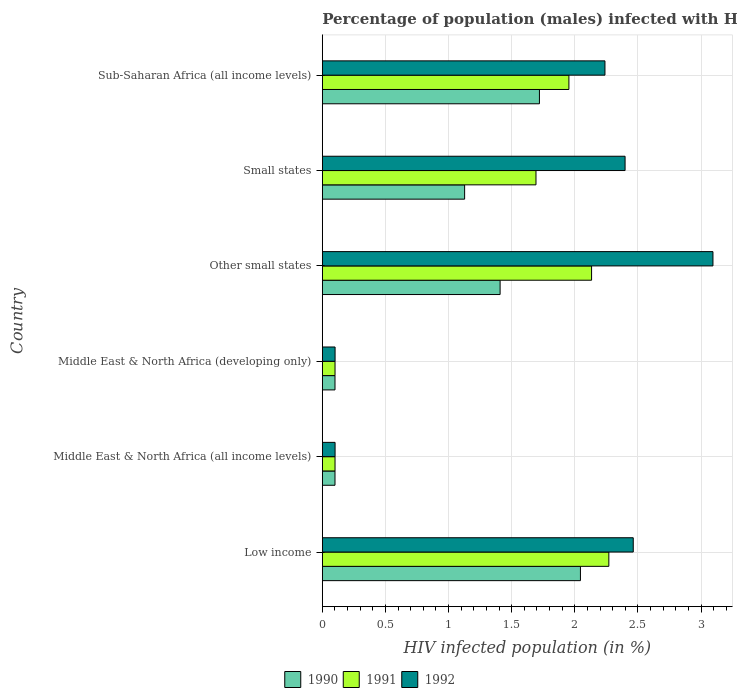How many different coloured bars are there?
Give a very brief answer. 3. How many groups of bars are there?
Ensure brevity in your answer.  6. Are the number of bars per tick equal to the number of legend labels?
Ensure brevity in your answer.  Yes. What is the label of the 1st group of bars from the top?
Your answer should be very brief. Sub-Saharan Africa (all income levels). In how many cases, is the number of bars for a given country not equal to the number of legend labels?
Your response must be concise. 0. What is the percentage of HIV infected male population in 1992 in Middle East & North Africa (developing only)?
Make the answer very short. 0.1. Across all countries, what is the maximum percentage of HIV infected male population in 1992?
Ensure brevity in your answer.  3.09. Across all countries, what is the minimum percentage of HIV infected male population in 1991?
Ensure brevity in your answer.  0.1. In which country was the percentage of HIV infected male population in 1992 maximum?
Your response must be concise. Other small states. In which country was the percentage of HIV infected male population in 1992 minimum?
Ensure brevity in your answer.  Middle East & North Africa (all income levels). What is the total percentage of HIV infected male population in 1990 in the graph?
Your response must be concise. 6.5. What is the difference between the percentage of HIV infected male population in 1992 in Other small states and that in Sub-Saharan Africa (all income levels)?
Ensure brevity in your answer.  0.86. What is the difference between the percentage of HIV infected male population in 1992 in Low income and the percentage of HIV infected male population in 1991 in Middle East & North Africa (all income levels)?
Provide a short and direct response. 2.36. What is the average percentage of HIV infected male population in 1991 per country?
Ensure brevity in your answer.  1.37. What is the difference between the percentage of HIV infected male population in 1991 and percentage of HIV infected male population in 1990 in Small states?
Ensure brevity in your answer.  0.57. What is the ratio of the percentage of HIV infected male population in 1990 in Small states to that in Sub-Saharan Africa (all income levels)?
Your response must be concise. 0.66. What is the difference between the highest and the second highest percentage of HIV infected male population in 1991?
Offer a terse response. 0.14. What is the difference between the highest and the lowest percentage of HIV infected male population in 1990?
Your answer should be very brief. 1.94. In how many countries, is the percentage of HIV infected male population in 1992 greater than the average percentage of HIV infected male population in 1992 taken over all countries?
Ensure brevity in your answer.  4. Is the sum of the percentage of HIV infected male population in 1991 in Low income and Middle East & North Africa (developing only) greater than the maximum percentage of HIV infected male population in 1992 across all countries?
Offer a very short reply. No. What does the 1st bar from the top in Other small states represents?
Provide a succinct answer. 1992. What does the 1st bar from the bottom in Small states represents?
Make the answer very short. 1990. How many bars are there?
Give a very brief answer. 18. Are the values on the major ticks of X-axis written in scientific E-notation?
Make the answer very short. No. Does the graph contain grids?
Ensure brevity in your answer.  Yes. How many legend labels are there?
Keep it short and to the point. 3. How are the legend labels stacked?
Keep it short and to the point. Horizontal. What is the title of the graph?
Your answer should be very brief. Percentage of population (males) infected with HIV. Does "2005" appear as one of the legend labels in the graph?
Ensure brevity in your answer.  No. What is the label or title of the X-axis?
Provide a short and direct response. HIV infected population (in %). What is the label or title of the Y-axis?
Your response must be concise. Country. What is the HIV infected population (in %) in 1990 in Low income?
Your answer should be very brief. 2.04. What is the HIV infected population (in %) of 1991 in Low income?
Make the answer very short. 2.27. What is the HIV infected population (in %) of 1992 in Low income?
Make the answer very short. 2.46. What is the HIV infected population (in %) in 1990 in Middle East & North Africa (all income levels)?
Provide a succinct answer. 0.1. What is the HIV infected population (in %) in 1991 in Middle East & North Africa (all income levels)?
Offer a very short reply. 0.1. What is the HIV infected population (in %) of 1992 in Middle East & North Africa (all income levels)?
Provide a short and direct response. 0.1. What is the HIV infected population (in %) in 1990 in Middle East & North Africa (developing only)?
Provide a succinct answer. 0.1. What is the HIV infected population (in %) in 1991 in Middle East & North Africa (developing only)?
Make the answer very short. 0.1. What is the HIV infected population (in %) in 1992 in Middle East & North Africa (developing only)?
Your answer should be compact. 0.1. What is the HIV infected population (in %) of 1990 in Other small states?
Your response must be concise. 1.41. What is the HIV infected population (in %) of 1991 in Other small states?
Make the answer very short. 2.13. What is the HIV infected population (in %) of 1992 in Other small states?
Offer a very short reply. 3.09. What is the HIV infected population (in %) in 1990 in Small states?
Offer a very short reply. 1.13. What is the HIV infected population (in %) in 1991 in Small states?
Offer a terse response. 1.69. What is the HIV infected population (in %) of 1992 in Small states?
Your answer should be very brief. 2.4. What is the HIV infected population (in %) of 1990 in Sub-Saharan Africa (all income levels)?
Your response must be concise. 1.72. What is the HIV infected population (in %) of 1991 in Sub-Saharan Africa (all income levels)?
Your answer should be compact. 1.95. What is the HIV infected population (in %) of 1992 in Sub-Saharan Africa (all income levels)?
Ensure brevity in your answer.  2.24. Across all countries, what is the maximum HIV infected population (in %) of 1990?
Your answer should be compact. 2.04. Across all countries, what is the maximum HIV infected population (in %) in 1991?
Make the answer very short. 2.27. Across all countries, what is the maximum HIV infected population (in %) of 1992?
Provide a succinct answer. 3.09. Across all countries, what is the minimum HIV infected population (in %) in 1990?
Provide a short and direct response. 0.1. Across all countries, what is the minimum HIV infected population (in %) in 1991?
Your answer should be compact. 0.1. Across all countries, what is the minimum HIV infected population (in %) in 1992?
Offer a terse response. 0.1. What is the total HIV infected population (in %) of 1990 in the graph?
Ensure brevity in your answer.  6.5. What is the total HIV infected population (in %) in 1991 in the graph?
Ensure brevity in your answer.  8.25. What is the total HIV infected population (in %) in 1992 in the graph?
Keep it short and to the point. 10.39. What is the difference between the HIV infected population (in %) in 1990 in Low income and that in Middle East & North Africa (all income levels)?
Provide a short and direct response. 1.94. What is the difference between the HIV infected population (in %) of 1991 in Low income and that in Middle East & North Africa (all income levels)?
Your answer should be compact. 2.17. What is the difference between the HIV infected population (in %) in 1992 in Low income and that in Middle East & North Africa (all income levels)?
Offer a very short reply. 2.36. What is the difference between the HIV infected population (in %) of 1990 in Low income and that in Middle East & North Africa (developing only)?
Your answer should be very brief. 1.94. What is the difference between the HIV infected population (in %) in 1991 in Low income and that in Middle East & North Africa (developing only)?
Offer a very short reply. 2.17. What is the difference between the HIV infected population (in %) of 1992 in Low income and that in Middle East & North Africa (developing only)?
Ensure brevity in your answer.  2.36. What is the difference between the HIV infected population (in %) in 1990 in Low income and that in Other small states?
Your response must be concise. 0.64. What is the difference between the HIV infected population (in %) of 1991 in Low income and that in Other small states?
Ensure brevity in your answer.  0.14. What is the difference between the HIV infected population (in %) in 1992 in Low income and that in Other small states?
Offer a terse response. -0.63. What is the difference between the HIV infected population (in %) in 1990 in Low income and that in Small states?
Offer a very short reply. 0.92. What is the difference between the HIV infected population (in %) of 1991 in Low income and that in Small states?
Offer a terse response. 0.58. What is the difference between the HIV infected population (in %) in 1992 in Low income and that in Small states?
Make the answer very short. 0.06. What is the difference between the HIV infected population (in %) of 1990 in Low income and that in Sub-Saharan Africa (all income levels)?
Offer a very short reply. 0.32. What is the difference between the HIV infected population (in %) of 1991 in Low income and that in Sub-Saharan Africa (all income levels)?
Ensure brevity in your answer.  0.32. What is the difference between the HIV infected population (in %) of 1992 in Low income and that in Sub-Saharan Africa (all income levels)?
Offer a terse response. 0.22. What is the difference between the HIV infected population (in %) in 1991 in Middle East & North Africa (all income levels) and that in Middle East & North Africa (developing only)?
Ensure brevity in your answer.  -0. What is the difference between the HIV infected population (in %) of 1990 in Middle East & North Africa (all income levels) and that in Other small states?
Provide a succinct answer. -1.31. What is the difference between the HIV infected population (in %) in 1991 in Middle East & North Africa (all income levels) and that in Other small states?
Your answer should be compact. -2.03. What is the difference between the HIV infected population (in %) in 1992 in Middle East & North Africa (all income levels) and that in Other small states?
Keep it short and to the point. -2.99. What is the difference between the HIV infected population (in %) in 1990 in Middle East & North Africa (all income levels) and that in Small states?
Provide a short and direct response. -1.03. What is the difference between the HIV infected population (in %) of 1991 in Middle East & North Africa (all income levels) and that in Small states?
Your answer should be compact. -1.59. What is the difference between the HIV infected population (in %) of 1992 in Middle East & North Africa (all income levels) and that in Small states?
Ensure brevity in your answer.  -2.3. What is the difference between the HIV infected population (in %) of 1990 in Middle East & North Africa (all income levels) and that in Sub-Saharan Africa (all income levels)?
Provide a short and direct response. -1.62. What is the difference between the HIV infected population (in %) of 1991 in Middle East & North Africa (all income levels) and that in Sub-Saharan Africa (all income levels)?
Your answer should be very brief. -1.85. What is the difference between the HIV infected population (in %) of 1992 in Middle East & North Africa (all income levels) and that in Sub-Saharan Africa (all income levels)?
Give a very brief answer. -2.14. What is the difference between the HIV infected population (in %) of 1990 in Middle East & North Africa (developing only) and that in Other small states?
Give a very brief answer. -1.31. What is the difference between the HIV infected population (in %) of 1991 in Middle East & North Africa (developing only) and that in Other small states?
Offer a terse response. -2.03. What is the difference between the HIV infected population (in %) in 1992 in Middle East & North Africa (developing only) and that in Other small states?
Offer a terse response. -2.99. What is the difference between the HIV infected population (in %) in 1990 in Middle East & North Africa (developing only) and that in Small states?
Your answer should be very brief. -1.03. What is the difference between the HIV infected population (in %) in 1991 in Middle East & North Africa (developing only) and that in Small states?
Your answer should be compact. -1.59. What is the difference between the HIV infected population (in %) of 1992 in Middle East & North Africa (developing only) and that in Small states?
Keep it short and to the point. -2.3. What is the difference between the HIV infected population (in %) of 1990 in Middle East & North Africa (developing only) and that in Sub-Saharan Africa (all income levels)?
Ensure brevity in your answer.  -1.62. What is the difference between the HIV infected population (in %) in 1991 in Middle East & North Africa (developing only) and that in Sub-Saharan Africa (all income levels)?
Offer a very short reply. -1.85. What is the difference between the HIV infected population (in %) in 1992 in Middle East & North Africa (developing only) and that in Sub-Saharan Africa (all income levels)?
Provide a succinct answer. -2.14. What is the difference between the HIV infected population (in %) of 1990 in Other small states and that in Small states?
Give a very brief answer. 0.28. What is the difference between the HIV infected population (in %) of 1991 in Other small states and that in Small states?
Ensure brevity in your answer.  0.44. What is the difference between the HIV infected population (in %) of 1992 in Other small states and that in Small states?
Offer a terse response. 0.7. What is the difference between the HIV infected population (in %) of 1990 in Other small states and that in Sub-Saharan Africa (all income levels)?
Your response must be concise. -0.31. What is the difference between the HIV infected population (in %) in 1991 in Other small states and that in Sub-Saharan Africa (all income levels)?
Offer a very short reply. 0.18. What is the difference between the HIV infected population (in %) of 1992 in Other small states and that in Sub-Saharan Africa (all income levels)?
Give a very brief answer. 0.86. What is the difference between the HIV infected population (in %) in 1990 in Small states and that in Sub-Saharan Africa (all income levels)?
Ensure brevity in your answer.  -0.59. What is the difference between the HIV infected population (in %) of 1991 in Small states and that in Sub-Saharan Africa (all income levels)?
Provide a short and direct response. -0.26. What is the difference between the HIV infected population (in %) in 1992 in Small states and that in Sub-Saharan Africa (all income levels)?
Offer a terse response. 0.16. What is the difference between the HIV infected population (in %) in 1990 in Low income and the HIV infected population (in %) in 1991 in Middle East & North Africa (all income levels)?
Offer a very short reply. 1.94. What is the difference between the HIV infected population (in %) of 1990 in Low income and the HIV infected population (in %) of 1992 in Middle East & North Africa (all income levels)?
Keep it short and to the point. 1.94. What is the difference between the HIV infected population (in %) in 1991 in Low income and the HIV infected population (in %) in 1992 in Middle East & North Africa (all income levels)?
Your response must be concise. 2.17. What is the difference between the HIV infected population (in %) of 1990 in Low income and the HIV infected population (in %) of 1991 in Middle East & North Africa (developing only)?
Offer a very short reply. 1.94. What is the difference between the HIV infected population (in %) in 1990 in Low income and the HIV infected population (in %) in 1992 in Middle East & North Africa (developing only)?
Your answer should be compact. 1.94. What is the difference between the HIV infected population (in %) of 1991 in Low income and the HIV infected population (in %) of 1992 in Middle East & North Africa (developing only)?
Your answer should be compact. 2.17. What is the difference between the HIV infected population (in %) in 1990 in Low income and the HIV infected population (in %) in 1991 in Other small states?
Your answer should be compact. -0.09. What is the difference between the HIV infected population (in %) in 1990 in Low income and the HIV infected population (in %) in 1992 in Other small states?
Your answer should be very brief. -1.05. What is the difference between the HIV infected population (in %) in 1991 in Low income and the HIV infected population (in %) in 1992 in Other small states?
Your answer should be very brief. -0.82. What is the difference between the HIV infected population (in %) of 1990 in Low income and the HIV infected population (in %) of 1991 in Small states?
Give a very brief answer. 0.35. What is the difference between the HIV infected population (in %) of 1990 in Low income and the HIV infected population (in %) of 1992 in Small states?
Make the answer very short. -0.35. What is the difference between the HIV infected population (in %) in 1991 in Low income and the HIV infected population (in %) in 1992 in Small states?
Give a very brief answer. -0.13. What is the difference between the HIV infected population (in %) of 1990 in Low income and the HIV infected population (in %) of 1991 in Sub-Saharan Africa (all income levels)?
Provide a succinct answer. 0.09. What is the difference between the HIV infected population (in %) of 1990 in Low income and the HIV infected population (in %) of 1992 in Sub-Saharan Africa (all income levels)?
Your answer should be very brief. -0.19. What is the difference between the HIV infected population (in %) of 1991 in Low income and the HIV infected population (in %) of 1992 in Sub-Saharan Africa (all income levels)?
Keep it short and to the point. 0.03. What is the difference between the HIV infected population (in %) in 1990 in Middle East & North Africa (all income levels) and the HIV infected population (in %) in 1991 in Middle East & North Africa (developing only)?
Ensure brevity in your answer.  -0. What is the difference between the HIV infected population (in %) in 1990 in Middle East & North Africa (all income levels) and the HIV infected population (in %) in 1992 in Middle East & North Africa (developing only)?
Your answer should be compact. -0. What is the difference between the HIV infected population (in %) of 1991 in Middle East & North Africa (all income levels) and the HIV infected population (in %) of 1992 in Middle East & North Africa (developing only)?
Keep it short and to the point. -0. What is the difference between the HIV infected population (in %) of 1990 in Middle East & North Africa (all income levels) and the HIV infected population (in %) of 1991 in Other small states?
Offer a very short reply. -2.03. What is the difference between the HIV infected population (in %) of 1990 in Middle East & North Africa (all income levels) and the HIV infected population (in %) of 1992 in Other small states?
Your answer should be very brief. -2.99. What is the difference between the HIV infected population (in %) in 1991 in Middle East & North Africa (all income levels) and the HIV infected population (in %) in 1992 in Other small states?
Provide a succinct answer. -2.99. What is the difference between the HIV infected population (in %) of 1990 in Middle East & North Africa (all income levels) and the HIV infected population (in %) of 1991 in Small states?
Ensure brevity in your answer.  -1.59. What is the difference between the HIV infected population (in %) in 1990 in Middle East & North Africa (all income levels) and the HIV infected population (in %) in 1992 in Small states?
Make the answer very short. -2.3. What is the difference between the HIV infected population (in %) of 1991 in Middle East & North Africa (all income levels) and the HIV infected population (in %) of 1992 in Small states?
Keep it short and to the point. -2.3. What is the difference between the HIV infected population (in %) in 1990 in Middle East & North Africa (all income levels) and the HIV infected population (in %) in 1991 in Sub-Saharan Africa (all income levels)?
Offer a terse response. -1.85. What is the difference between the HIV infected population (in %) in 1990 in Middle East & North Africa (all income levels) and the HIV infected population (in %) in 1992 in Sub-Saharan Africa (all income levels)?
Provide a succinct answer. -2.14. What is the difference between the HIV infected population (in %) of 1991 in Middle East & North Africa (all income levels) and the HIV infected population (in %) of 1992 in Sub-Saharan Africa (all income levels)?
Offer a very short reply. -2.14. What is the difference between the HIV infected population (in %) in 1990 in Middle East & North Africa (developing only) and the HIV infected population (in %) in 1991 in Other small states?
Your answer should be very brief. -2.03. What is the difference between the HIV infected population (in %) in 1990 in Middle East & North Africa (developing only) and the HIV infected population (in %) in 1992 in Other small states?
Provide a succinct answer. -2.99. What is the difference between the HIV infected population (in %) in 1991 in Middle East & North Africa (developing only) and the HIV infected population (in %) in 1992 in Other small states?
Offer a very short reply. -2.99. What is the difference between the HIV infected population (in %) in 1990 in Middle East & North Africa (developing only) and the HIV infected population (in %) in 1991 in Small states?
Your answer should be compact. -1.59. What is the difference between the HIV infected population (in %) of 1990 in Middle East & North Africa (developing only) and the HIV infected population (in %) of 1992 in Small states?
Your response must be concise. -2.3. What is the difference between the HIV infected population (in %) in 1991 in Middle East & North Africa (developing only) and the HIV infected population (in %) in 1992 in Small states?
Keep it short and to the point. -2.3. What is the difference between the HIV infected population (in %) of 1990 in Middle East & North Africa (developing only) and the HIV infected population (in %) of 1991 in Sub-Saharan Africa (all income levels)?
Offer a terse response. -1.85. What is the difference between the HIV infected population (in %) in 1990 in Middle East & North Africa (developing only) and the HIV infected population (in %) in 1992 in Sub-Saharan Africa (all income levels)?
Your answer should be compact. -2.14. What is the difference between the HIV infected population (in %) of 1991 in Middle East & North Africa (developing only) and the HIV infected population (in %) of 1992 in Sub-Saharan Africa (all income levels)?
Keep it short and to the point. -2.14. What is the difference between the HIV infected population (in %) of 1990 in Other small states and the HIV infected population (in %) of 1991 in Small states?
Your response must be concise. -0.28. What is the difference between the HIV infected population (in %) in 1990 in Other small states and the HIV infected population (in %) in 1992 in Small states?
Provide a short and direct response. -0.99. What is the difference between the HIV infected population (in %) of 1991 in Other small states and the HIV infected population (in %) of 1992 in Small states?
Provide a short and direct response. -0.27. What is the difference between the HIV infected population (in %) of 1990 in Other small states and the HIV infected population (in %) of 1991 in Sub-Saharan Africa (all income levels)?
Ensure brevity in your answer.  -0.54. What is the difference between the HIV infected population (in %) of 1990 in Other small states and the HIV infected population (in %) of 1992 in Sub-Saharan Africa (all income levels)?
Your answer should be very brief. -0.83. What is the difference between the HIV infected population (in %) in 1991 in Other small states and the HIV infected population (in %) in 1992 in Sub-Saharan Africa (all income levels)?
Offer a very short reply. -0.11. What is the difference between the HIV infected population (in %) in 1990 in Small states and the HIV infected population (in %) in 1991 in Sub-Saharan Africa (all income levels)?
Give a very brief answer. -0.83. What is the difference between the HIV infected population (in %) in 1990 in Small states and the HIV infected population (in %) in 1992 in Sub-Saharan Africa (all income levels)?
Provide a short and direct response. -1.11. What is the difference between the HIV infected population (in %) in 1991 in Small states and the HIV infected population (in %) in 1992 in Sub-Saharan Africa (all income levels)?
Ensure brevity in your answer.  -0.55. What is the average HIV infected population (in %) of 1990 per country?
Provide a short and direct response. 1.08. What is the average HIV infected population (in %) of 1991 per country?
Offer a terse response. 1.37. What is the average HIV infected population (in %) in 1992 per country?
Your answer should be very brief. 1.73. What is the difference between the HIV infected population (in %) of 1990 and HIV infected population (in %) of 1991 in Low income?
Your response must be concise. -0.23. What is the difference between the HIV infected population (in %) in 1990 and HIV infected population (in %) in 1992 in Low income?
Your answer should be very brief. -0.42. What is the difference between the HIV infected population (in %) of 1991 and HIV infected population (in %) of 1992 in Low income?
Ensure brevity in your answer.  -0.19. What is the difference between the HIV infected population (in %) in 1990 and HIV infected population (in %) in 1991 in Middle East & North Africa (all income levels)?
Provide a succinct answer. -0. What is the difference between the HIV infected population (in %) of 1990 and HIV infected population (in %) of 1992 in Middle East & North Africa (all income levels)?
Provide a short and direct response. -0. What is the difference between the HIV infected population (in %) of 1991 and HIV infected population (in %) of 1992 in Middle East & North Africa (all income levels)?
Give a very brief answer. -0. What is the difference between the HIV infected population (in %) of 1990 and HIV infected population (in %) of 1991 in Middle East & North Africa (developing only)?
Offer a terse response. -0. What is the difference between the HIV infected population (in %) of 1990 and HIV infected population (in %) of 1992 in Middle East & North Africa (developing only)?
Your response must be concise. -0. What is the difference between the HIV infected population (in %) in 1991 and HIV infected population (in %) in 1992 in Middle East & North Africa (developing only)?
Offer a terse response. -0. What is the difference between the HIV infected population (in %) of 1990 and HIV infected population (in %) of 1991 in Other small states?
Your response must be concise. -0.72. What is the difference between the HIV infected population (in %) of 1990 and HIV infected population (in %) of 1992 in Other small states?
Your response must be concise. -1.69. What is the difference between the HIV infected population (in %) in 1991 and HIV infected population (in %) in 1992 in Other small states?
Provide a succinct answer. -0.96. What is the difference between the HIV infected population (in %) in 1990 and HIV infected population (in %) in 1991 in Small states?
Your answer should be compact. -0.57. What is the difference between the HIV infected population (in %) in 1990 and HIV infected population (in %) in 1992 in Small states?
Your answer should be very brief. -1.27. What is the difference between the HIV infected population (in %) in 1991 and HIV infected population (in %) in 1992 in Small states?
Provide a succinct answer. -0.71. What is the difference between the HIV infected population (in %) of 1990 and HIV infected population (in %) of 1991 in Sub-Saharan Africa (all income levels)?
Your answer should be very brief. -0.23. What is the difference between the HIV infected population (in %) in 1990 and HIV infected population (in %) in 1992 in Sub-Saharan Africa (all income levels)?
Offer a very short reply. -0.52. What is the difference between the HIV infected population (in %) of 1991 and HIV infected population (in %) of 1992 in Sub-Saharan Africa (all income levels)?
Offer a terse response. -0.29. What is the ratio of the HIV infected population (in %) of 1990 in Low income to that in Middle East & North Africa (all income levels)?
Give a very brief answer. 20.38. What is the ratio of the HIV infected population (in %) of 1991 in Low income to that in Middle East & North Africa (all income levels)?
Provide a succinct answer. 22.55. What is the ratio of the HIV infected population (in %) of 1992 in Low income to that in Middle East & North Africa (all income levels)?
Make the answer very short. 24.4. What is the ratio of the HIV infected population (in %) of 1990 in Low income to that in Middle East & North Africa (developing only)?
Your response must be concise. 20.38. What is the ratio of the HIV infected population (in %) in 1991 in Low income to that in Middle East & North Africa (developing only)?
Keep it short and to the point. 22.55. What is the ratio of the HIV infected population (in %) of 1992 in Low income to that in Middle East & North Africa (developing only)?
Offer a very short reply. 24.4. What is the ratio of the HIV infected population (in %) of 1990 in Low income to that in Other small states?
Provide a short and direct response. 1.45. What is the ratio of the HIV infected population (in %) in 1991 in Low income to that in Other small states?
Your response must be concise. 1.06. What is the ratio of the HIV infected population (in %) in 1992 in Low income to that in Other small states?
Provide a succinct answer. 0.8. What is the ratio of the HIV infected population (in %) of 1990 in Low income to that in Small states?
Ensure brevity in your answer.  1.81. What is the ratio of the HIV infected population (in %) in 1991 in Low income to that in Small states?
Make the answer very short. 1.34. What is the ratio of the HIV infected population (in %) of 1990 in Low income to that in Sub-Saharan Africa (all income levels)?
Your response must be concise. 1.19. What is the ratio of the HIV infected population (in %) of 1991 in Low income to that in Sub-Saharan Africa (all income levels)?
Make the answer very short. 1.16. What is the ratio of the HIV infected population (in %) in 1992 in Low income to that in Sub-Saharan Africa (all income levels)?
Give a very brief answer. 1.1. What is the ratio of the HIV infected population (in %) in 1991 in Middle East & North Africa (all income levels) to that in Middle East & North Africa (developing only)?
Your answer should be very brief. 1. What is the ratio of the HIV infected population (in %) in 1992 in Middle East & North Africa (all income levels) to that in Middle East & North Africa (developing only)?
Provide a succinct answer. 1. What is the ratio of the HIV infected population (in %) of 1990 in Middle East & North Africa (all income levels) to that in Other small states?
Give a very brief answer. 0.07. What is the ratio of the HIV infected population (in %) in 1991 in Middle East & North Africa (all income levels) to that in Other small states?
Provide a succinct answer. 0.05. What is the ratio of the HIV infected population (in %) in 1992 in Middle East & North Africa (all income levels) to that in Other small states?
Make the answer very short. 0.03. What is the ratio of the HIV infected population (in %) of 1990 in Middle East & North Africa (all income levels) to that in Small states?
Provide a succinct answer. 0.09. What is the ratio of the HIV infected population (in %) of 1991 in Middle East & North Africa (all income levels) to that in Small states?
Give a very brief answer. 0.06. What is the ratio of the HIV infected population (in %) of 1992 in Middle East & North Africa (all income levels) to that in Small states?
Offer a very short reply. 0.04. What is the ratio of the HIV infected population (in %) of 1990 in Middle East & North Africa (all income levels) to that in Sub-Saharan Africa (all income levels)?
Make the answer very short. 0.06. What is the ratio of the HIV infected population (in %) of 1991 in Middle East & North Africa (all income levels) to that in Sub-Saharan Africa (all income levels)?
Provide a succinct answer. 0.05. What is the ratio of the HIV infected population (in %) of 1992 in Middle East & North Africa (all income levels) to that in Sub-Saharan Africa (all income levels)?
Your answer should be very brief. 0.05. What is the ratio of the HIV infected population (in %) of 1990 in Middle East & North Africa (developing only) to that in Other small states?
Ensure brevity in your answer.  0.07. What is the ratio of the HIV infected population (in %) of 1991 in Middle East & North Africa (developing only) to that in Other small states?
Offer a terse response. 0.05. What is the ratio of the HIV infected population (in %) in 1992 in Middle East & North Africa (developing only) to that in Other small states?
Offer a terse response. 0.03. What is the ratio of the HIV infected population (in %) of 1990 in Middle East & North Africa (developing only) to that in Small states?
Offer a very short reply. 0.09. What is the ratio of the HIV infected population (in %) of 1991 in Middle East & North Africa (developing only) to that in Small states?
Offer a very short reply. 0.06. What is the ratio of the HIV infected population (in %) in 1992 in Middle East & North Africa (developing only) to that in Small states?
Offer a terse response. 0.04. What is the ratio of the HIV infected population (in %) of 1990 in Middle East & North Africa (developing only) to that in Sub-Saharan Africa (all income levels)?
Provide a succinct answer. 0.06. What is the ratio of the HIV infected population (in %) of 1991 in Middle East & North Africa (developing only) to that in Sub-Saharan Africa (all income levels)?
Your answer should be very brief. 0.05. What is the ratio of the HIV infected population (in %) in 1992 in Middle East & North Africa (developing only) to that in Sub-Saharan Africa (all income levels)?
Offer a terse response. 0.05. What is the ratio of the HIV infected population (in %) in 1990 in Other small states to that in Small states?
Keep it short and to the point. 1.25. What is the ratio of the HIV infected population (in %) in 1991 in Other small states to that in Small states?
Your response must be concise. 1.26. What is the ratio of the HIV infected population (in %) in 1992 in Other small states to that in Small states?
Your answer should be compact. 1.29. What is the ratio of the HIV infected population (in %) of 1990 in Other small states to that in Sub-Saharan Africa (all income levels)?
Your answer should be compact. 0.82. What is the ratio of the HIV infected population (in %) of 1991 in Other small states to that in Sub-Saharan Africa (all income levels)?
Your response must be concise. 1.09. What is the ratio of the HIV infected population (in %) in 1992 in Other small states to that in Sub-Saharan Africa (all income levels)?
Offer a terse response. 1.38. What is the ratio of the HIV infected population (in %) in 1990 in Small states to that in Sub-Saharan Africa (all income levels)?
Ensure brevity in your answer.  0.66. What is the ratio of the HIV infected population (in %) in 1991 in Small states to that in Sub-Saharan Africa (all income levels)?
Provide a succinct answer. 0.87. What is the ratio of the HIV infected population (in %) in 1992 in Small states to that in Sub-Saharan Africa (all income levels)?
Ensure brevity in your answer.  1.07. What is the difference between the highest and the second highest HIV infected population (in %) in 1990?
Your answer should be very brief. 0.32. What is the difference between the highest and the second highest HIV infected population (in %) of 1991?
Give a very brief answer. 0.14. What is the difference between the highest and the second highest HIV infected population (in %) of 1992?
Make the answer very short. 0.63. What is the difference between the highest and the lowest HIV infected population (in %) of 1990?
Give a very brief answer. 1.94. What is the difference between the highest and the lowest HIV infected population (in %) of 1991?
Keep it short and to the point. 2.17. What is the difference between the highest and the lowest HIV infected population (in %) in 1992?
Ensure brevity in your answer.  2.99. 